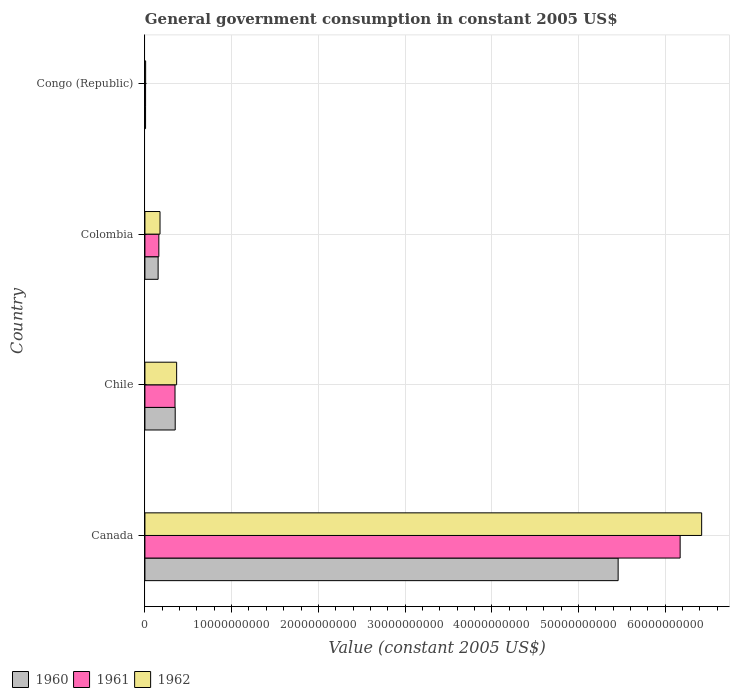How many groups of bars are there?
Keep it short and to the point. 4. Are the number of bars per tick equal to the number of legend labels?
Ensure brevity in your answer.  Yes. How many bars are there on the 1st tick from the bottom?
Your response must be concise. 3. What is the label of the 4th group of bars from the top?
Provide a short and direct response. Canada. In how many cases, is the number of bars for a given country not equal to the number of legend labels?
Provide a short and direct response. 0. What is the government conusmption in 1961 in Canada?
Make the answer very short. 6.17e+1. Across all countries, what is the maximum government conusmption in 1961?
Your answer should be very brief. 6.17e+1. Across all countries, what is the minimum government conusmption in 1961?
Offer a very short reply. 7.67e+07. In which country was the government conusmption in 1960 minimum?
Your answer should be very brief. Congo (Republic). What is the total government conusmption in 1960 in the graph?
Make the answer very short. 5.97e+1. What is the difference between the government conusmption in 1962 in Chile and that in Congo (Republic)?
Make the answer very short. 3.57e+09. What is the difference between the government conusmption in 1961 in Canada and the government conusmption in 1962 in Congo (Republic)?
Make the answer very short. 6.16e+1. What is the average government conusmption in 1961 per country?
Your answer should be compact. 1.67e+1. What is the difference between the government conusmption in 1960 and government conusmption in 1962 in Canada?
Keep it short and to the point. -9.63e+09. What is the ratio of the government conusmption in 1960 in Chile to that in Congo (Republic)?
Provide a succinct answer. 46.93. Is the government conusmption in 1962 in Chile less than that in Colombia?
Your answer should be compact. No. Is the difference between the government conusmption in 1960 in Canada and Congo (Republic) greater than the difference between the government conusmption in 1962 in Canada and Congo (Republic)?
Offer a very short reply. No. What is the difference between the highest and the second highest government conusmption in 1960?
Provide a short and direct response. 5.11e+1. What is the difference between the highest and the lowest government conusmption in 1960?
Ensure brevity in your answer.  5.45e+1. In how many countries, is the government conusmption in 1961 greater than the average government conusmption in 1961 taken over all countries?
Keep it short and to the point. 1. What does the 1st bar from the top in Chile represents?
Your answer should be very brief. 1962. What does the 1st bar from the bottom in Congo (Republic) represents?
Provide a succinct answer. 1960. Is it the case that in every country, the sum of the government conusmption in 1960 and government conusmption in 1961 is greater than the government conusmption in 1962?
Your answer should be very brief. Yes. How many bars are there?
Ensure brevity in your answer.  12. Are all the bars in the graph horizontal?
Offer a very short reply. Yes. How many countries are there in the graph?
Offer a terse response. 4. Does the graph contain any zero values?
Provide a short and direct response. No. Does the graph contain grids?
Provide a short and direct response. Yes. Where does the legend appear in the graph?
Offer a terse response. Bottom left. How are the legend labels stacked?
Keep it short and to the point. Horizontal. What is the title of the graph?
Make the answer very short. General government consumption in constant 2005 US$. What is the label or title of the X-axis?
Your answer should be very brief. Value (constant 2005 US$). What is the Value (constant 2005 US$) of 1960 in Canada?
Your response must be concise. 5.46e+1. What is the Value (constant 2005 US$) in 1961 in Canada?
Your answer should be compact. 6.17e+1. What is the Value (constant 2005 US$) of 1962 in Canada?
Provide a short and direct response. 6.42e+1. What is the Value (constant 2005 US$) in 1960 in Chile?
Your answer should be compact. 3.49e+09. What is the Value (constant 2005 US$) of 1961 in Chile?
Your response must be concise. 3.47e+09. What is the Value (constant 2005 US$) of 1962 in Chile?
Your response must be concise. 3.66e+09. What is the Value (constant 2005 US$) of 1960 in Colombia?
Your answer should be very brief. 1.52e+09. What is the Value (constant 2005 US$) of 1961 in Colombia?
Ensure brevity in your answer.  1.61e+09. What is the Value (constant 2005 US$) of 1962 in Colombia?
Provide a succinct answer. 1.74e+09. What is the Value (constant 2005 US$) in 1960 in Congo (Republic)?
Your answer should be compact. 7.44e+07. What is the Value (constant 2005 US$) of 1961 in Congo (Republic)?
Ensure brevity in your answer.  7.67e+07. What is the Value (constant 2005 US$) in 1962 in Congo (Republic)?
Offer a terse response. 8.33e+07. Across all countries, what is the maximum Value (constant 2005 US$) in 1960?
Keep it short and to the point. 5.46e+1. Across all countries, what is the maximum Value (constant 2005 US$) of 1961?
Ensure brevity in your answer.  6.17e+1. Across all countries, what is the maximum Value (constant 2005 US$) in 1962?
Offer a very short reply. 6.42e+1. Across all countries, what is the minimum Value (constant 2005 US$) of 1960?
Offer a very short reply. 7.44e+07. Across all countries, what is the minimum Value (constant 2005 US$) in 1961?
Your answer should be compact. 7.67e+07. Across all countries, what is the minimum Value (constant 2005 US$) of 1962?
Offer a terse response. 8.33e+07. What is the total Value (constant 2005 US$) in 1960 in the graph?
Offer a terse response. 5.97e+1. What is the total Value (constant 2005 US$) in 1961 in the graph?
Offer a terse response. 6.69e+1. What is the total Value (constant 2005 US$) in 1962 in the graph?
Your answer should be compact. 6.97e+1. What is the difference between the Value (constant 2005 US$) in 1960 in Canada and that in Chile?
Your answer should be very brief. 5.11e+1. What is the difference between the Value (constant 2005 US$) in 1961 in Canada and that in Chile?
Your answer should be very brief. 5.83e+1. What is the difference between the Value (constant 2005 US$) of 1962 in Canada and that in Chile?
Your answer should be very brief. 6.05e+1. What is the difference between the Value (constant 2005 US$) in 1960 in Canada and that in Colombia?
Your response must be concise. 5.31e+1. What is the difference between the Value (constant 2005 US$) of 1961 in Canada and that in Colombia?
Ensure brevity in your answer.  6.01e+1. What is the difference between the Value (constant 2005 US$) in 1962 in Canada and that in Colombia?
Your answer should be very brief. 6.25e+1. What is the difference between the Value (constant 2005 US$) of 1960 in Canada and that in Congo (Republic)?
Your response must be concise. 5.45e+1. What is the difference between the Value (constant 2005 US$) of 1961 in Canada and that in Congo (Republic)?
Offer a terse response. 6.16e+1. What is the difference between the Value (constant 2005 US$) of 1962 in Canada and that in Congo (Republic)?
Give a very brief answer. 6.41e+1. What is the difference between the Value (constant 2005 US$) of 1960 in Chile and that in Colombia?
Give a very brief answer. 1.97e+09. What is the difference between the Value (constant 2005 US$) in 1961 in Chile and that in Colombia?
Your response must be concise. 1.86e+09. What is the difference between the Value (constant 2005 US$) of 1962 in Chile and that in Colombia?
Offer a very short reply. 1.92e+09. What is the difference between the Value (constant 2005 US$) in 1960 in Chile and that in Congo (Republic)?
Ensure brevity in your answer.  3.42e+09. What is the difference between the Value (constant 2005 US$) in 1961 in Chile and that in Congo (Republic)?
Your response must be concise. 3.39e+09. What is the difference between the Value (constant 2005 US$) in 1962 in Chile and that in Congo (Republic)?
Give a very brief answer. 3.57e+09. What is the difference between the Value (constant 2005 US$) in 1960 in Colombia and that in Congo (Republic)?
Your answer should be very brief. 1.45e+09. What is the difference between the Value (constant 2005 US$) of 1961 in Colombia and that in Congo (Republic)?
Ensure brevity in your answer.  1.53e+09. What is the difference between the Value (constant 2005 US$) of 1962 in Colombia and that in Congo (Republic)?
Your response must be concise. 1.66e+09. What is the difference between the Value (constant 2005 US$) in 1960 in Canada and the Value (constant 2005 US$) in 1961 in Chile?
Provide a short and direct response. 5.11e+1. What is the difference between the Value (constant 2005 US$) in 1960 in Canada and the Value (constant 2005 US$) in 1962 in Chile?
Your response must be concise. 5.09e+1. What is the difference between the Value (constant 2005 US$) of 1961 in Canada and the Value (constant 2005 US$) of 1962 in Chile?
Your answer should be very brief. 5.81e+1. What is the difference between the Value (constant 2005 US$) in 1960 in Canada and the Value (constant 2005 US$) in 1961 in Colombia?
Your response must be concise. 5.30e+1. What is the difference between the Value (constant 2005 US$) of 1960 in Canada and the Value (constant 2005 US$) of 1962 in Colombia?
Your answer should be compact. 5.28e+1. What is the difference between the Value (constant 2005 US$) in 1961 in Canada and the Value (constant 2005 US$) in 1962 in Colombia?
Make the answer very short. 6.00e+1. What is the difference between the Value (constant 2005 US$) of 1960 in Canada and the Value (constant 2005 US$) of 1961 in Congo (Republic)?
Your response must be concise. 5.45e+1. What is the difference between the Value (constant 2005 US$) in 1960 in Canada and the Value (constant 2005 US$) in 1962 in Congo (Republic)?
Your response must be concise. 5.45e+1. What is the difference between the Value (constant 2005 US$) in 1961 in Canada and the Value (constant 2005 US$) in 1962 in Congo (Republic)?
Provide a short and direct response. 6.16e+1. What is the difference between the Value (constant 2005 US$) in 1960 in Chile and the Value (constant 2005 US$) in 1961 in Colombia?
Your answer should be very brief. 1.89e+09. What is the difference between the Value (constant 2005 US$) in 1960 in Chile and the Value (constant 2005 US$) in 1962 in Colombia?
Your response must be concise. 1.75e+09. What is the difference between the Value (constant 2005 US$) of 1961 in Chile and the Value (constant 2005 US$) of 1962 in Colombia?
Ensure brevity in your answer.  1.73e+09. What is the difference between the Value (constant 2005 US$) of 1960 in Chile and the Value (constant 2005 US$) of 1961 in Congo (Republic)?
Ensure brevity in your answer.  3.42e+09. What is the difference between the Value (constant 2005 US$) of 1960 in Chile and the Value (constant 2005 US$) of 1962 in Congo (Republic)?
Make the answer very short. 3.41e+09. What is the difference between the Value (constant 2005 US$) of 1961 in Chile and the Value (constant 2005 US$) of 1962 in Congo (Republic)?
Provide a succinct answer. 3.39e+09. What is the difference between the Value (constant 2005 US$) in 1960 in Colombia and the Value (constant 2005 US$) in 1961 in Congo (Republic)?
Make the answer very short. 1.45e+09. What is the difference between the Value (constant 2005 US$) of 1960 in Colombia and the Value (constant 2005 US$) of 1962 in Congo (Republic)?
Offer a terse response. 1.44e+09. What is the difference between the Value (constant 2005 US$) of 1961 in Colombia and the Value (constant 2005 US$) of 1962 in Congo (Republic)?
Your answer should be compact. 1.52e+09. What is the average Value (constant 2005 US$) of 1960 per country?
Provide a short and direct response. 1.49e+1. What is the average Value (constant 2005 US$) of 1961 per country?
Your answer should be compact. 1.67e+1. What is the average Value (constant 2005 US$) of 1962 per country?
Keep it short and to the point. 1.74e+1. What is the difference between the Value (constant 2005 US$) in 1960 and Value (constant 2005 US$) in 1961 in Canada?
Keep it short and to the point. -7.15e+09. What is the difference between the Value (constant 2005 US$) in 1960 and Value (constant 2005 US$) in 1962 in Canada?
Your response must be concise. -9.63e+09. What is the difference between the Value (constant 2005 US$) in 1961 and Value (constant 2005 US$) in 1962 in Canada?
Your answer should be compact. -2.48e+09. What is the difference between the Value (constant 2005 US$) of 1960 and Value (constant 2005 US$) of 1961 in Chile?
Your answer should be very brief. 2.27e+07. What is the difference between the Value (constant 2005 US$) of 1960 and Value (constant 2005 US$) of 1962 in Chile?
Offer a very short reply. -1.64e+08. What is the difference between the Value (constant 2005 US$) in 1961 and Value (constant 2005 US$) in 1962 in Chile?
Give a very brief answer. -1.87e+08. What is the difference between the Value (constant 2005 US$) of 1960 and Value (constant 2005 US$) of 1961 in Colombia?
Offer a terse response. -8.37e+07. What is the difference between the Value (constant 2005 US$) in 1960 and Value (constant 2005 US$) in 1962 in Colombia?
Ensure brevity in your answer.  -2.18e+08. What is the difference between the Value (constant 2005 US$) of 1961 and Value (constant 2005 US$) of 1962 in Colombia?
Provide a succinct answer. -1.34e+08. What is the difference between the Value (constant 2005 US$) in 1960 and Value (constant 2005 US$) in 1961 in Congo (Republic)?
Provide a succinct answer. -2.22e+06. What is the difference between the Value (constant 2005 US$) of 1960 and Value (constant 2005 US$) of 1962 in Congo (Republic)?
Provide a succinct answer. -8.89e+06. What is the difference between the Value (constant 2005 US$) of 1961 and Value (constant 2005 US$) of 1962 in Congo (Republic)?
Ensure brevity in your answer.  -6.67e+06. What is the ratio of the Value (constant 2005 US$) of 1960 in Canada to that in Chile?
Your response must be concise. 15.62. What is the ratio of the Value (constant 2005 US$) in 1961 in Canada to that in Chile?
Make the answer very short. 17.78. What is the ratio of the Value (constant 2005 US$) in 1962 in Canada to that in Chile?
Provide a succinct answer. 17.55. What is the ratio of the Value (constant 2005 US$) in 1960 in Canada to that in Colombia?
Make the answer very short. 35.84. What is the ratio of the Value (constant 2005 US$) in 1961 in Canada to that in Colombia?
Your answer should be very brief. 38.42. What is the ratio of the Value (constant 2005 US$) in 1962 in Canada to that in Colombia?
Make the answer very short. 36.89. What is the ratio of the Value (constant 2005 US$) in 1960 in Canada to that in Congo (Republic)?
Offer a terse response. 733.2. What is the ratio of the Value (constant 2005 US$) in 1961 in Canada to that in Congo (Republic)?
Offer a very short reply. 805.21. What is the ratio of the Value (constant 2005 US$) of 1962 in Canada to that in Congo (Republic)?
Offer a very short reply. 770.58. What is the ratio of the Value (constant 2005 US$) in 1960 in Chile to that in Colombia?
Ensure brevity in your answer.  2.29. What is the ratio of the Value (constant 2005 US$) in 1961 in Chile to that in Colombia?
Your answer should be compact. 2.16. What is the ratio of the Value (constant 2005 US$) of 1962 in Chile to that in Colombia?
Keep it short and to the point. 2.1. What is the ratio of the Value (constant 2005 US$) in 1960 in Chile to that in Congo (Republic)?
Provide a short and direct response. 46.93. What is the ratio of the Value (constant 2005 US$) in 1961 in Chile to that in Congo (Republic)?
Offer a terse response. 45.28. What is the ratio of the Value (constant 2005 US$) of 1962 in Chile to that in Congo (Republic)?
Your response must be concise. 43.9. What is the ratio of the Value (constant 2005 US$) of 1960 in Colombia to that in Congo (Republic)?
Provide a succinct answer. 20.46. What is the ratio of the Value (constant 2005 US$) of 1961 in Colombia to that in Congo (Republic)?
Your answer should be very brief. 20.96. What is the ratio of the Value (constant 2005 US$) in 1962 in Colombia to that in Congo (Republic)?
Offer a terse response. 20.89. What is the difference between the highest and the second highest Value (constant 2005 US$) in 1960?
Give a very brief answer. 5.11e+1. What is the difference between the highest and the second highest Value (constant 2005 US$) of 1961?
Provide a short and direct response. 5.83e+1. What is the difference between the highest and the second highest Value (constant 2005 US$) of 1962?
Ensure brevity in your answer.  6.05e+1. What is the difference between the highest and the lowest Value (constant 2005 US$) in 1960?
Your response must be concise. 5.45e+1. What is the difference between the highest and the lowest Value (constant 2005 US$) in 1961?
Your answer should be very brief. 6.16e+1. What is the difference between the highest and the lowest Value (constant 2005 US$) of 1962?
Provide a short and direct response. 6.41e+1. 